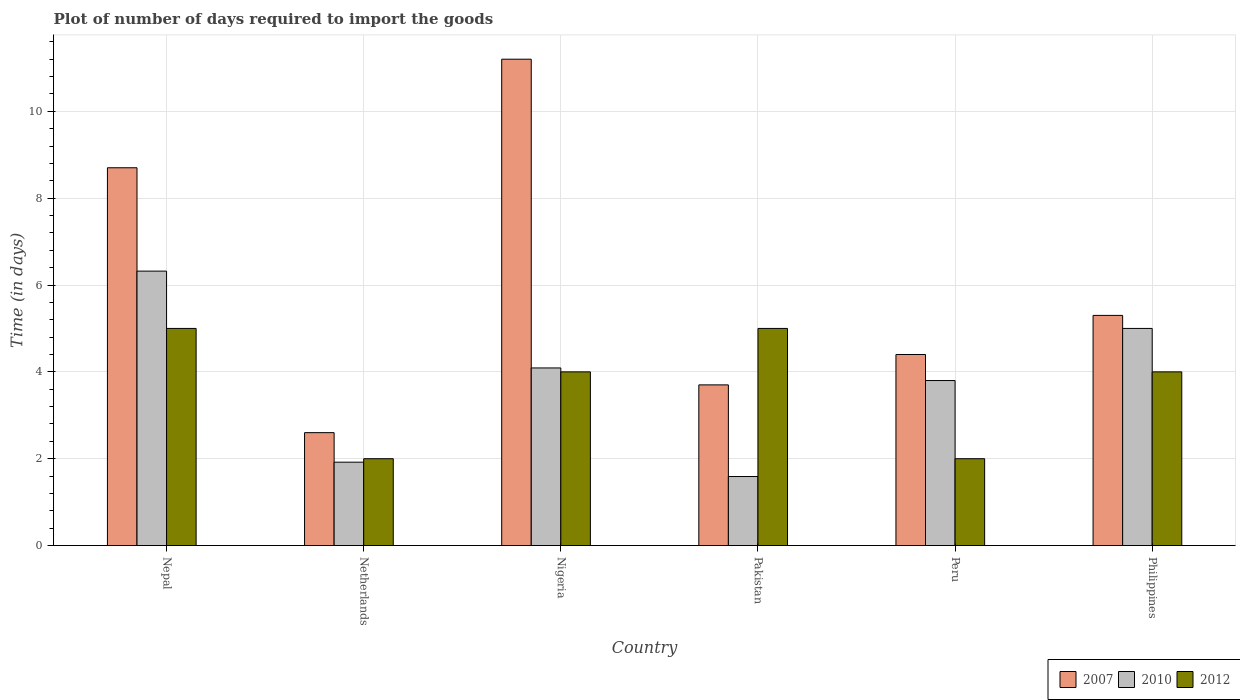How many groups of bars are there?
Give a very brief answer. 6. Are the number of bars on each tick of the X-axis equal?
Offer a terse response. Yes. How many bars are there on the 4th tick from the right?
Offer a very short reply. 3. What is the label of the 1st group of bars from the left?
Your answer should be very brief. Nepal. In which country was the time required to import goods in 2012 maximum?
Your answer should be very brief. Nepal. In which country was the time required to import goods in 2010 minimum?
Provide a succinct answer. Pakistan. What is the total time required to import goods in 2007 in the graph?
Keep it short and to the point. 35.9. What is the difference between the time required to import goods in 2010 in Netherlands and that in Philippines?
Your answer should be compact. -3.08. What is the difference between the time required to import goods in 2012 in Philippines and the time required to import goods in 2010 in Pakistan?
Ensure brevity in your answer.  2.41. What is the average time required to import goods in 2010 per country?
Offer a terse response. 3.79. What is the difference between the time required to import goods of/in 2012 and time required to import goods of/in 2010 in Netherlands?
Offer a terse response. 0.08. In how many countries, is the time required to import goods in 2010 greater than 4 days?
Keep it short and to the point. 3. What is the ratio of the time required to import goods in 2010 in Nepal to that in Pakistan?
Give a very brief answer. 3.97. Is the time required to import goods in 2007 in Nepal less than that in Pakistan?
Your answer should be very brief. No. In how many countries, is the time required to import goods in 2007 greater than the average time required to import goods in 2007 taken over all countries?
Keep it short and to the point. 2. Is the sum of the time required to import goods in 2007 in Nepal and Nigeria greater than the maximum time required to import goods in 2010 across all countries?
Your answer should be compact. Yes. Are all the bars in the graph horizontal?
Provide a succinct answer. No. How many countries are there in the graph?
Offer a terse response. 6. Are the values on the major ticks of Y-axis written in scientific E-notation?
Your answer should be very brief. No. Does the graph contain grids?
Ensure brevity in your answer.  Yes. How are the legend labels stacked?
Make the answer very short. Horizontal. What is the title of the graph?
Your response must be concise. Plot of number of days required to import the goods. What is the label or title of the X-axis?
Your answer should be compact. Country. What is the label or title of the Y-axis?
Ensure brevity in your answer.  Time (in days). What is the Time (in days) of 2007 in Nepal?
Your answer should be very brief. 8.7. What is the Time (in days) in 2010 in Nepal?
Ensure brevity in your answer.  6.32. What is the Time (in days) in 2010 in Netherlands?
Provide a short and direct response. 1.92. What is the Time (in days) of 2012 in Netherlands?
Make the answer very short. 2. What is the Time (in days) in 2007 in Nigeria?
Offer a terse response. 11.2. What is the Time (in days) in 2010 in Nigeria?
Your response must be concise. 4.09. What is the Time (in days) in 2012 in Nigeria?
Provide a succinct answer. 4. What is the Time (in days) in 2010 in Pakistan?
Make the answer very short. 1.59. What is the Time (in days) of 2007 in Peru?
Provide a succinct answer. 4.4. What is the Time (in days) in 2010 in Peru?
Keep it short and to the point. 3.8. What is the Time (in days) of 2010 in Philippines?
Give a very brief answer. 5. What is the Time (in days) in 2012 in Philippines?
Offer a very short reply. 4. Across all countries, what is the maximum Time (in days) of 2007?
Make the answer very short. 11.2. Across all countries, what is the maximum Time (in days) of 2010?
Offer a very short reply. 6.32. Across all countries, what is the maximum Time (in days) in 2012?
Your answer should be compact. 5. Across all countries, what is the minimum Time (in days) of 2007?
Provide a succinct answer. 2.6. Across all countries, what is the minimum Time (in days) in 2010?
Ensure brevity in your answer.  1.59. Across all countries, what is the minimum Time (in days) of 2012?
Your answer should be very brief. 2. What is the total Time (in days) in 2007 in the graph?
Make the answer very short. 35.9. What is the total Time (in days) of 2010 in the graph?
Offer a very short reply. 22.72. What is the total Time (in days) of 2012 in the graph?
Provide a short and direct response. 22. What is the difference between the Time (in days) in 2007 in Nepal and that in Netherlands?
Your answer should be compact. 6.1. What is the difference between the Time (in days) of 2007 in Nepal and that in Nigeria?
Offer a very short reply. -2.5. What is the difference between the Time (in days) in 2010 in Nepal and that in Nigeria?
Make the answer very short. 2.23. What is the difference between the Time (in days) of 2007 in Nepal and that in Pakistan?
Provide a short and direct response. 5. What is the difference between the Time (in days) in 2010 in Nepal and that in Pakistan?
Give a very brief answer. 4.73. What is the difference between the Time (in days) of 2007 in Nepal and that in Peru?
Your answer should be very brief. 4.3. What is the difference between the Time (in days) in 2010 in Nepal and that in Peru?
Keep it short and to the point. 2.52. What is the difference between the Time (in days) in 2010 in Nepal and that in Philippines?
Make the answer very short. 1.32. What is the difference between the Time (in days) of 2012 in Nepal and that in Philippines?
Your answer should be compact. 1. What is the difference between the Time (in days) of 2007 in Netherlands and that in Nigeria?
Give a very brief answer. -8.6. What is the difference between the Time (in days) of 2010 in Netherlands and that in Nigeria?
Offer a terse response. -2.17. What is the difference between the Time (in days) in 2010 in Netherlands and that in Pakistan?
Your answer should be compact. 0.33. What is the difference between the Time (in days) in 2012 in Netherlands and that in Pakistan?
Provide a short and direct response. -3. What is the difference between the Time (in days) of 2007 in Netherlands and that in Peru?
Ensure brevity in your answer.  -1.8. What is the difference between the Time (in days) of 2010 in Netherlands and that in Peru?
Offer a terse response. -1.88. What is the difference between the Time (in days) in 2012 in Netherlands and that in Peru?
Your answer should be very brief. 0. What is the difference between the Time (in days) in 2010 in Netherlands and that in Philippines?
Provide a short and direct response. -3.08. What is the difference between the Time (in days) in 2010 in Nigeria and that in Pakistan?
Keep it short and to the point. 2.5. What is the difference between the Time (in days) in 2012 in Nigeria and that in Pakistan?
Give a very brief answer. -1. What is the difference between the Time (in days) in 2010 in Nigeria and that in Peru?
Make the answer very short. 0.29. What is the difference between the Time (in days) of 2012 in Nigeria and that in Peru?
Your answer should be compact. 2. What is the difference between the Time (in days) of 2007 in Nigeria and that in Philippines?
Offer a terse response. 5.9. What is the difference between the Time (in days) of 2010 in Nigeria and that in Philippines?
Provide a short and direct response. -0.91. What is the difference between the Time (in days) in 2012 in Nigeria and that in Philippines?
Provide a short and direct response. 0. What is the difference between the Time (in days) in 2010 in Pakistan and that in Peru?
Ensure brevity in your answer.  -2.21. What is the difference between the Time (in days) in 2012 in Pakistan and that in Peru?
Provide a succinct answer. 3. What is the difference between the Time (in days) of 2007 in Pakistan and that in Philippines?
Ensure brevity in your answer.  -1.6. What is the difference between the Time (in days) in 2010 in Pakistan and that in Philippines?
Offer a terse response. -3.41. What is the difference between the Time (in days) of 2012 in Pakistan and that in Philippines?
Offer a terse response. 1. What is the difference between the Time (in days) of 2010 in Peru and that in Philippines?
Offer a terse response. -1.2. What is the difference between the Time (in days) of 2007 in Nepal and the Time (in days) of 2010 in Netherlands?
Provide a succinct answer. 6.78. What is the difference between the Time (in days) in 2010 in Nepal and the Time (in days) in 2012 in Netherlands?
Keep it short and to the point. 4.32. What is the difference between the Time (in days) of 2007 in Nepal and the Time (in days) of 2010 in Nigeria?
Offer a terse response. 4.61. What is the difference between the Time (in days) in 2007 in Nepal and the Time (in days) in 2012 in Nigeria?
Your response must be concise. 4.7. What is the difference between the Time (in days) in 2010 in Nepal and the Time (in days) in 2012 in Nigeria?
Give a very brief answer. 2.32. What is the difference between the Time (in days) in 2007 in Nepal and the Time (in days) in 2010 in Pakistan?
Offer a very short reply. 7.11. What is the difference between the Time (in days) of 2010 in Nepal and the Time (in days) of 2012 in Pakistan?
Give a very brief answer. 1.32. What is the difference between the Time (in days) in 2007 in Nepal and the Time (in days) in 2010 in Peru?
Make the answer very short. 4.9. What is the difference between the Time (in days) of 2007 in Nepal and the Time (in days) of 2012 in Peru?
Give a very brief answer. 6.7. What is the difference between the Time (in days) in 2010 in Nepal and the Time (in days) in 2012 in Peru?
Make the answer very short. 4.32. What is the difference between the Time (in days) in 2010 in Nepal and the Time (in days) in 2012 in Philippines?
Keep it short and to the point. 2.32. What is the difference between the Time (in days) of 2007 in Netherlands and the Time (in days) of 2010 in Nigeria?
Give a very brief answer. -1.49. What is the difference between the Time (in days) of 2007 in Netherlands and the Time (in days) of 2012 in Nigeria?
Make the answer very short. -1.4. What is the difference between the Time (in days) in 2010 in Netherlands and the Time (in days) in 2012 in Nigeria?
Keep it short and to the point. -2.08. What is the difference between the Time (in days) of 2010 in Netherlands and the Time (in days) of 2012 in Pakistan?
Ensure brevity in your answer.  -3.08. What is the difference between the Time (in days) of 2007 in Netherlands and the Time (in days) of 2010 in Peru?
Offer a very short reply. -1.2. What is the difference between the Time (in days) of 2010 in Netherlands and the Time (in days) of 2012 in Peru?
Your answer should be very brief. -0.08. What is the difference between the Time (in days) of 2007 in Netherlands and the Time (in days) of 2012 in Philippines?
Your response must be concise. -1.4. What is the difference between the Time (in days) of 2010 in Netherlands and the Time (in days) of 2012 in Philippines?
Provide a succinct answer. -2.08. What is the difference between the Time (in days) in 2007 in Nigeria and the Time (in days) in 2010 in Pakistan?
Your answer should be compact. 9.61. What is the difference between the Time (in days) of 2010 in Nigeria and the Time (in days) of 2012 in Pakistan?
Make the answer very short. -0.91. What is the difference between the Time (in days) of 2007 in Nigeria and the Time (in days) of 2012 in Peru?
Give a very brief answer. 9.2. What is the difference between the Time (in days) of 2010 in Nigeria and the Time (in days) of 2012 in Peru?
Provide a short and direct response. 2.09. What is the difference between the Time (in days) of 2007 in Nigeria and the Time (in days) of 2010 in Philippines?
Give a very brief answer. 6.2. What is the difference between the Time (in days) of 2007 in Nigeria and the Time (in days) of 2012 in Philippines?
Give a very brief answer. 7.2. What is the difference between the Time (in days) in 2010 in Nigeria and the Time (in days) in 2012 in Philippines?
Keep it short and to the point. 0.09. What is the difference between the Time (in days) in 2010 in Pakistan and the Time (in days) in 2012 in Peru?
Your answer should be very brief. -0.41. What is the difference between the Time (in days) of 2007 in Pakistan and the Time (in days) of 2010 in Philippines?
Offer a very short reply. -1.3. What is the difference between the Time (in days) in 2007 in Pakistan and the Time (in days) in 2012 in Philippines?
Give a very brief answer. -0.3. What is the difference between the Time (in days) of 2010 in Pakistan and the Time (in days) of 2012 in Philippines?
Offer a terse response. -2.41. What is the difference between the Time (in days) in 2007 in Peru and the Time (in days) in 2012 in Philippines?
Your answer should be compact. 0.4. What is the difference between the Time (in days) in 2010 in Peru and the Time (in days) in 2012 in Philippines?
Offer a very short reply. -0.2. What is the average Time (in days) of 2007 per country?
Ensure brevity in your answer.  5.98. What is the average Time (in days) in 2010 per country?
Ensure brevity in your answer.  3.79. What is the average Time (in days) in 2012 per country?
Your answer should be very brief. 3.67. What is the difference between the Time (in days) in 2007 and Time (in days) in 2010 in Nepal?
Give a very brief answer. 2.38. What is the difference between the Time (in days) of 2010 and Time (in days) of 2012 in Nepal?
Provide a succinct answer. 1.32. What is the difference between the Time (in days) in 2007 and Time (in days) in 2010 in Netherlands?
Offer a very short reply. 0.68. What is the difference between the Time (in days) in 2007 and Time (in days) in 2012 in Netherlands?
Offer a very short reply. 0.6. What is the difference between the Time (in days) of 2010 and Time (in days) of 2012 in Netherlands?
Keep it short and to the point. -0.08. What is the difference between the Time (in days) of 2007 and Time (in days) of 2010 in Nigeria?
Make the answer very short. 7.11. What is the difference between the Time (in days) in 2007 and Time (in days) in 2012 in Nigeria?
Provide a succinct answer. 7.2. What is the difference between the Time (in days) in 2010 and Time (in days) in 2012 in Nigeria?
Offer a very short reply. 0.09. What is the difference between the Time (in days) in 2007 and Time (in days) in 2010 in Pakistan?
Provide a short and direct response. 2.11. What is the difference between the Time (in days) of 2007 and Time (in days) of 2012 in Pakistan?
Offer a terse response. -1.3. What is the difference between the Time (in days) in 2010 and Time (in days) in 2012 in Pakistan?
Offer a terse response. -3.41. What is the difference between the Time (in days) of 2007 and Time (in days) of 2010 in Peru?
Your response must be concise. 0.6. What is the difference between the Time (in days) of 2007 and Time (in days) of 2012 in Peru?
Your answer should be very brief. 2.4. What is the difference between the Time (in days) in 2010 and Time (in days) in 2012 in Peru?
Your answer should be very brief. 1.8. What is the difference between the Time (in days) in 2010 and Time (in days) in 2012 in Philippines?
Offer a terse response. 1. What is the ratio of the Time (in days) of 2007 in Nepal to that in Netherlands?
Your answer should be very brief. 3.35. What is the ratio of the Time (in days) in 2010 in Nepal to that in Netherlands?
Give a very brief answer. 3.29. What is the ratio of the Time (in days) of 2012 in Nepal to that in Netherlands?
Provide a succinct answer. 2.5. What is the ratio of the Time (in days) in 2007 in Nepal to that in Nigeria?
Offer a terse response. 0.78. What is the ratio of the Time (in days) of 2010 in Nepal to that in Nigeria?
Your answer should be very brief. 1.55. What is the ratio of the Time (in days) of 2007 in Nepal to that in Pakistan?
Give a very brief answer. 2.35. What is the ratio of the Time (in days) of 2010 in Nepal to that in Pakistan?
Your answer should be compact. 3.97. What is the ratio of the Time (in days) of 2012 in Nepal to that in Pakistan?
Your response must be concise. 1. What is the ratio of the Time (in days) in 2007 in Nepal to that in Peru?
Keep it short and to the point. 1.98. What is the ratio of the Time (in days) in 2010 in Nepal to that in Peru?
Offer a terse response. 1.66. What is the ratio of the Time (in days) in 2012 in Nepal to that in Peru?
Make the answer very short. 2.5. What is the ratio of the Time (in days) of 2007 in Nepal to that in Philippines?
Offer a very short reply. 1.64. What is the ratio of the Time (in days) of 2010 in Nepal to that in Philippines?
Provide a succinct answer. 1.26. What is the ratio of the Time (in days) of 2012 in Nepal to that in Philippines?
Offer a very short reply. 1.25. What is the ratio of the Time (in days) in 2007 in Netherlands to that in Nigeria?
Your answer should be very brief. 0.23. What is the ratio of the Time (in days) in 2010 in Netherlands to that in Nigeria?
Offer a very short reply. 0.47. What is the ratio of the Time (in days) of 2007 in Netherlands to that in Pakistan?
Make the answer very short. 0.7. What is the ratio of the Time (in days) of 2010 in Netherlands to that in Pakistan?
Provide a short and direct response. 1.21. What is the ratio of the Time (in days) of 2007 in Netherlands to that in Peru?
Offer a very short reply. 0.59. What is the ratio of the Time (in days) of 2010 in Netherlands to that in Peru?
Offer a very short reply. 0.51. What is the ratio of the Time (in days) in 2007 in Netherlands to that in Philippines?
Your answer should be very brief. 0.49. What is the ratio of the Time (in days) in 2010 in Netherlands to that in Philippines?
Offer a very short reply. 0.38. What is the ratio of the Time (in days) of 2007 in Nigeria to that in Pakistan?
Ensure brevity in your answer.  3.03. What is the ratio of the Time (in days) in 2010 in Nigeria to that in Pakistan?
Make the answer very short. 2.57. What is the ratio of the Time (in days) in 2012 in Nigeria to that in Pakistan?
Your answer should be compact. 0.8. What is the ratio of the Time (in days) in 2007 in Nigeria to that in Peru?
Provide a succinct answer. 2.55. What is the ratio of the Time (in days) in 2010 in Nigeria to that in Peru?
Keep it short and to the point. 1.08. What is the ratio of the Time (in days) of 2007 in Nigeria to that in Philippines?
Provide a succinct answer. 2.11. What is the ratio of the Time (in days) in 2010 in Nigeria to that in Philippines?
Your answer should be very brief. 0.82. What is the ratio of the Time (in days) in 2007 in Pakistan to that in Peru?
Provide a succinct answer. 0.84. What is the ratio of the Time (in days) in 2010 in Pakistan to that in Peru?
Your answer should be compact. 0.42. What is the ratio of the Time (in days) of 2012 in Pakistan to that in Peru?
Your answer should be very brief. 2.5. What is the ratio of the Time (in days) of 2007 in Pakistan to that in Philippines?
Keep it short and to the point. 0.7. What is the ratio of the Time (in days) of 2010 in Pakistan to that in Philippines?
Your answer should be very brief. 0.32. What is the ratio of the Time (in days) in 2007 in Peru to that in Philippines?
Your answer should be compact. 0.83. What is the ratio of the Time (in days) of 2010 in Peru to that in Philippines?
Offer a very short reply. 0.76. What is the ratio of the Time (in days) of 2012 in Peru to that in Philippines?
Offer a very short reply. 0.5. What is the difference between the highest and the second highest Time (in days) of 2010?
Keep it short and to the point. 1.32. What is the difference between the highest and the lowest Time (in days) in 2007?
Offer a terse response. 8.6. What is the difference between the highest and the lowest Time (in days) in 2010?
Offer a very short reply. 4.73. 